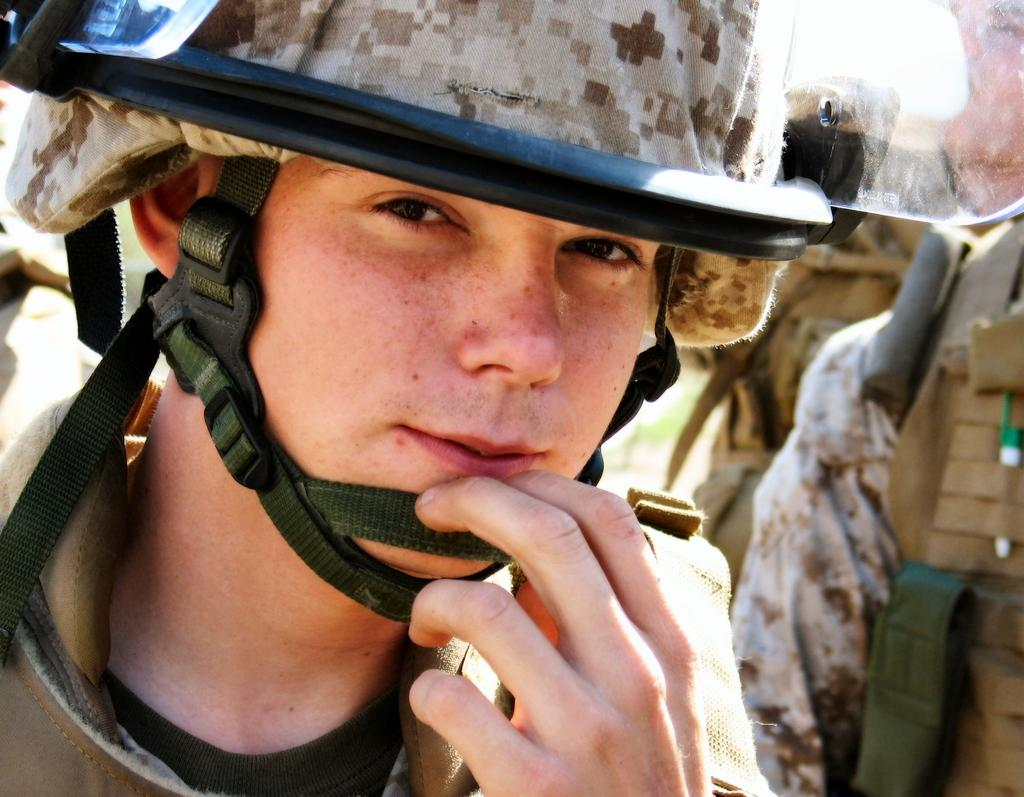What is the person in the image wearing on their head? The person in the image is wearing a helmet. What are the people behind the person wearing a helmet holding? The people behind the person wearing a helmet are holding backpacks. What type of birds can be seen flying in the image? There are no birds visible in the image. What kind of doll is sitting on the person's shoulder in the image? There is no doll present in the image. 